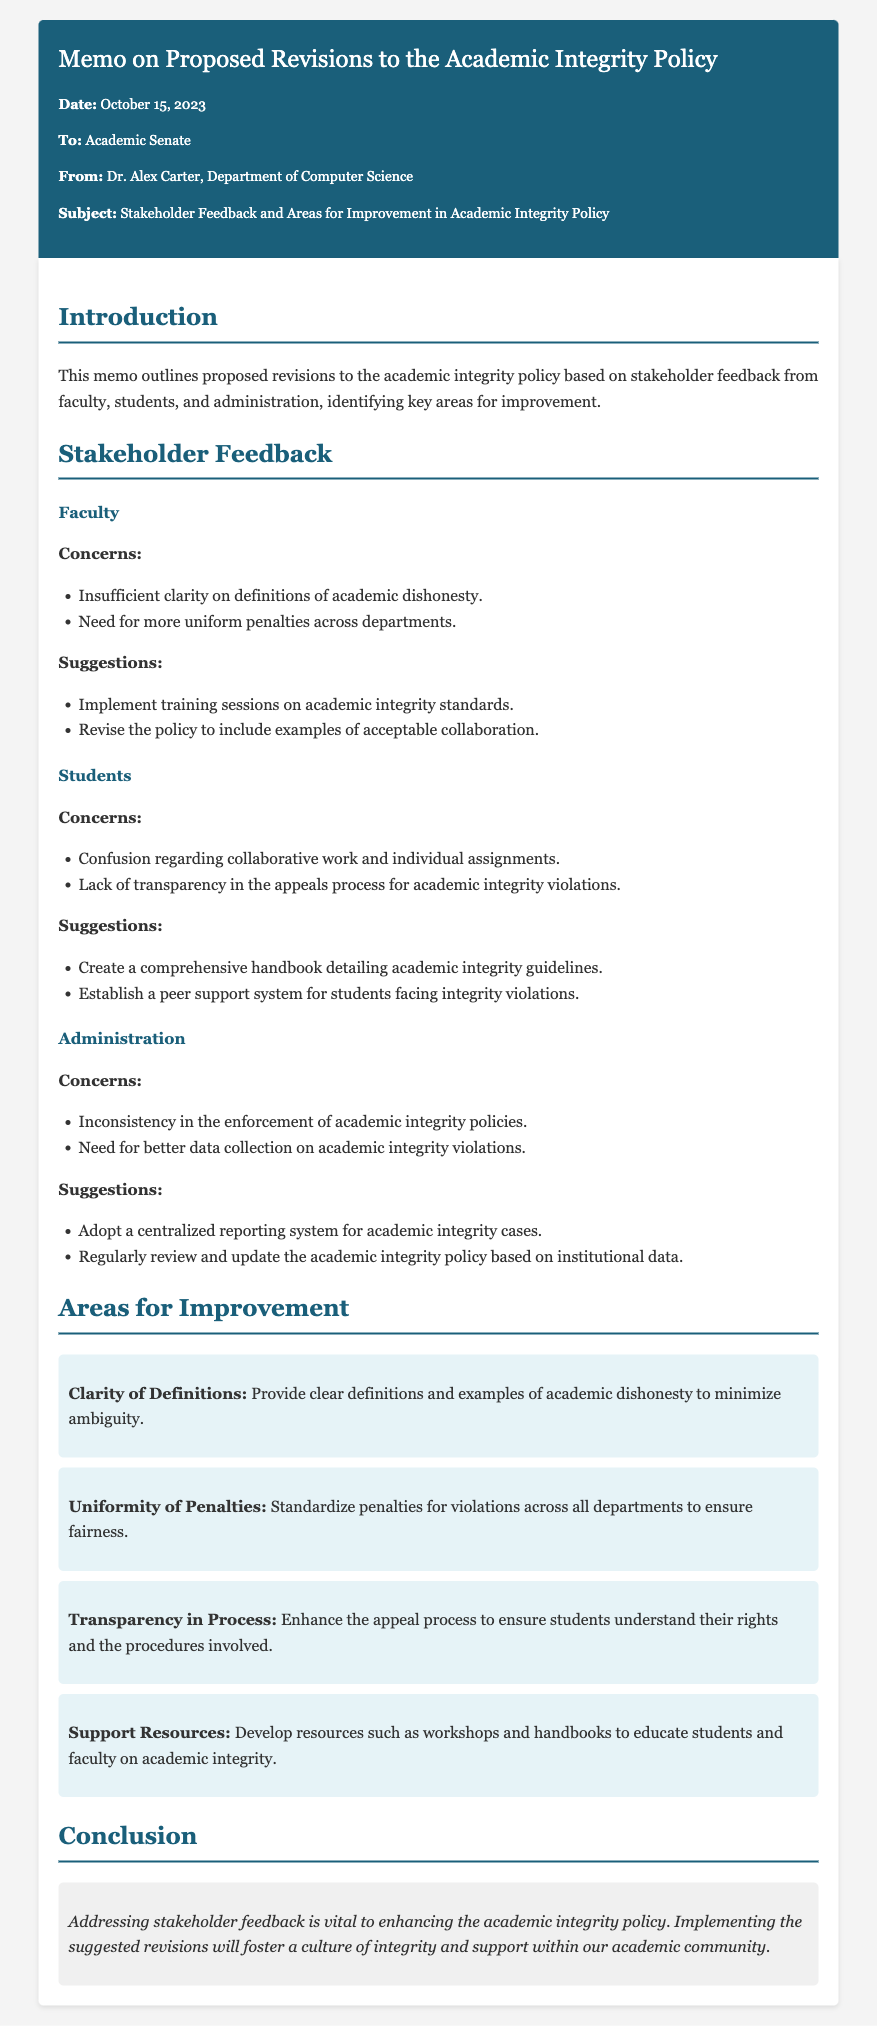what is the date of the memo? The date of the memo is stated in the memo details section as October 15, 2023.
Answer: October 15, 2023 who is the author of the memo? The author of the memo is listed as Dr. Alex Carter in the memo details.
Answer: Dr. Alex Carter what is one concern raised by faculty? One of the concerns raised by faculty is about insufficient clarity on definitions of academic dishonesty.
Answer: Insufficient clarity on definitions of academic dishonesty what suggestion do students have regarding academic integrity guidelines? Students suggest creating a comprehensive handbook detailing academic integrity guidelines.
Answer: Create a comprehensive handbook detailing academic integrity guidelines what area for improvement focuses on penalty consistency? The area for improvement that focuses on penalty consistency is titled "Uniformity of Penalties."
Answer: Uniformity of Penalties how many stakeholder sections are highlighted in the memo? The memo highlights three stakeholder sections: Faculty, Students, and Administration.
Answer: Three what does the conclusion emphasize about stakeholder feedback? The conclusion emphasizes that addressing stakeholder feedback is vital to enhancing the academic integrity policy.
Answer: Vital to enhancing the academic integrity policy what type of document is this? This document is a memo, specified by its structure and purpose in communicating proposed revisions.
Answer: Memo 